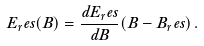Convert formula to latex. <formula><loc_0><loc_0><loc_500><loc_500>E _ { r } e s ( B ) = \frac { d E _ { r } e s } { d B } ( B - B _ { r } e s ) \, .</formula> 